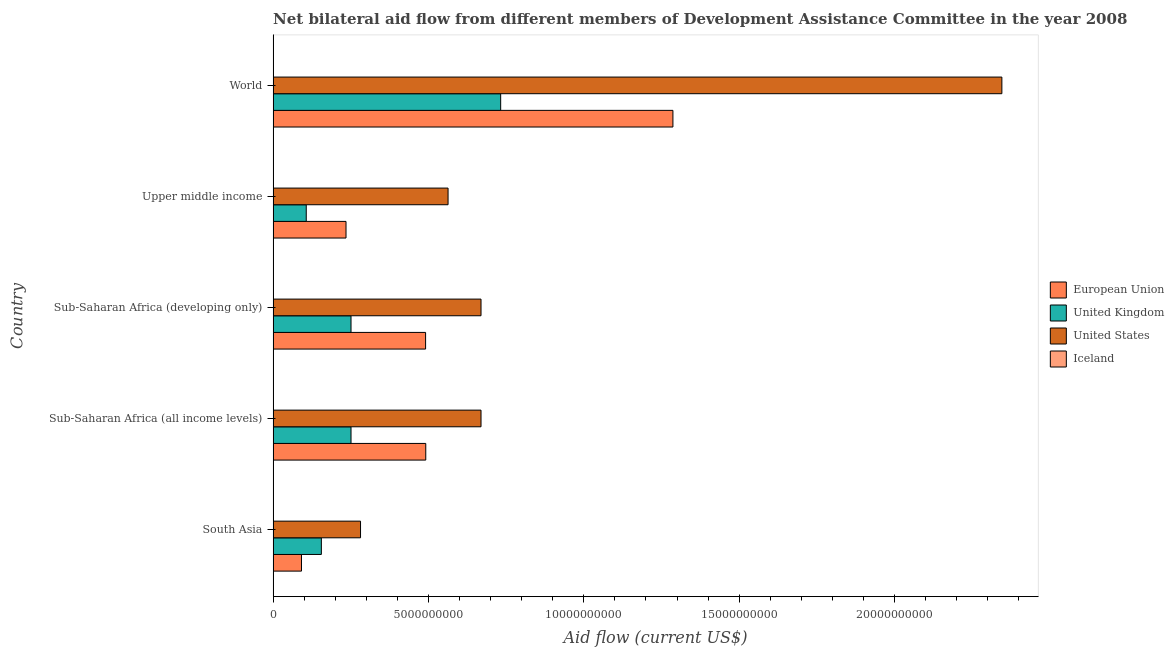How many groups of bars are there?
Make the answer very short. 5. Are the number of bars per tick equal to the number of legend labels?
Make the answer very short. Yes. Are the number of bars on each tick of the Y-axis equal?
Ensure brevity in your answer.  Yes. How many bars are there on the 5th tick from the top?
Provide a succinct answer. 4. How many bars are there on the 2nd tick from the bottom?
Your answer should be compact. 4. What is the label of the 5th group of bars from the top?
Make the answer very short. South Asia. In how many cases, is the number of bars for a given country not equal to the number of legend labels?
Your answer should be compact. 0. What is the amount of aid given by iceland in Sub-Saharan Africa (all income levels)?
Keep it short and to the point. 5.30e+05. Across all countries, what is the maximum amount of aid given by iceland?
Your response must be concise. 5.13e+06. Across all countries, what is the minimum amount of aid given by uk?
Keep it short and to the point. 1.07e+09. In which country was the amount of aid given by uk maximum?
Your response must be concise. World. In which country was the amount of aid given by iceland minimum?
Ensure brevity in your answer.  Sub-Saharan Africa (all income levels). What is the total amount of aid given by eu in the graph?
Make the answer very short. 2.59e+1. What is the difference between the amount of aid given by uk in South Asia and that in Sub-Saharan Africa (developing only)?
Make the answer very short. -9.54e+08. What is the difference between the amount of aid given by eu in South Asia and the amount of aid given by uk in World?
Offer a terse response. -6.41e+09. What is the average amount of aid given by eu per country?
Your response must be concise. 5.19e+09. What is the difference between the amount of aid given by us and amount of aid given by uk in Sub-Saharan Africa (developing only)?
Your response must be concise. 4.18e+09. In how many countries, is the amount of aid given by eu greater than 1000000000 US$?
Give a very brief answer. 4. What is the ratio of the amount of aid given by iceland in Sub-Saharan Africa (developing only) to that in Upper middle income?
Make the answer very short. 1.44. Is the difference between the amount of aid given by iceland in Sub-Saharan Africa (developing only) and World greater than the difference between the amount of aid given by us in Sub-Saharan Africa (developing only) and World?
Make the answer very short. Yes. What is the difference between the highest and the second highest amount of aid given by us?
Ensure brevity in your answer.  1.68e+1. What is the difference between the highest and the lowest amount of aid given by uk?
Offer a terse response. 6.26e+09. What is the difference between two consecutive major ticks on the X-axis?
Offer a very short reply. 5.00e+09. Does the graph contain any zero values?
Keep it short and to the point. No. Does the graph contain grids?
Give a very brief answer. No. How many legend labels are there?
Provide a short and direct response. 4. How are the legend labels stacked?
Provide a short and direct response. Vertical. What is the title of the graph?
Your answer should be compact. Net bilateral aid flow from different members of Development Assistance Committee in the year 2008. What is the Aid flow (current US$) in European Union in South Asia?
Keep it short and to the point. 9.13e+08. What is the Aid flow (current US$) of United Kingdom in South Asia?
Ensure brevity in your answer.  1.55e+09. What is the Aid flow (current US$) in United States in South Asia?
Offer a very short reply. 2.81e+09. What is the Aid flow (current US$) of European Union in Sub-Saharan Africa (all income levels)?
Keep it short and to the point. 4.91e+09. What is the Aid flow (current US$) in United Kingdom in Sub-Saharan Africa (all income levels)?
Make the answer very short. 2.51e+09. What is the Aid flow (current US$) in United States in Sub-Saharan Africa (all income levels)?
Give a very brief answer. 6.69e+09. What is the Aid flow (current US$) of Iceland in Sub-Saharan Africa (all income levels)?
Your answer should be very brief. 5.30e+05. What is the Aid flow (current US$) of European Union in Sub-Saharan Africa (developing only)?
Your answer should be very brief. 4.91e+09. What is the Aid flow (current US$) in United Kingdom in Sub-Saharan Africa (developing only)?
Provide a short and direct response. 2.51e+09. What is the Aid flow (current US$) of United States in Sub-Saharan Africa (developing only)?
Give a very brief answer. 6.69e+09. What is the Aid flow (current US$) of Iceland in Sub-Saharan Africa (developing only)?
Provide a succinct answer. 5.13e+06. What is the Aid flow (current US$) in European Union in Upper middle income?
Offer a terse response. 2.35e+09. What is the Aid flow (current US$) of United Kingdom in Upper middle income?
Provide a short and direct response. 1.07e+09. What is the Aid flow (current US$) in United States in Upper middle income?
Give a very brief answer. 5.63e+09. What is the Aid flow (current US$) of Iceland in Upper middle income?
Ensure brevity in your answer.  3.57e+06. What is the Aid flow (current US$) of European Union in World?
Provide a succinct answer. 1.29e+1. What is the Aid flow (current US$) of United Kingdom in World?
Give a very brief answer. 7.32e+09. What is the Aid flow (current US$) in United States in World?
Your answer should be compact. 2.35e+1. What is the Aid flow (current US$) in Iceland in World?
Provide a succinct answer. 2.64e+06. Across all countries, what is the maximum Aid flow (current US$) in European Union?
Your answer should be very brief. 1.29e+1. Across all countries, what is the maximum Aid flow (current US$) of United Kingdom?
Keep it short and to the point. 7.32e+09. Across all countries, what is the maximum Aid flow (current US$) of United States?
Provide a short and direct response. 2.35e+1. Across all countries, what is the maximum Aid flow (current US$) of Iceland?
Give a very brief answer. 5.13e+06. Across all countries, what is the minimum Aid flow (current US$) of European Union?
Provide a short and direct response. 9.13e+08. Across all countries, what is the minimum Aid flow (current US$) in United Kingdom?
Provide a succinct answer. 1.07e+09. Across all countries, what is the minimum Aid flow (current US$) of United States?
Your answer should be very brief. 2.81e+09. Across all countries, what is the minimum Aid flow (current US$) of Iceland?
Your answer should be compact. 5.30e+05. What is the total Aid flow (current US$) of European Union in the graph?
Offer a terse response. 2.59e+1. What is the total Aid flow (current US$) of United Kingdom in the graph?
Your answer should be compact. 1.50e+1. What is the total Aid flow (current US$) of United States in the graph?
Give a very brief answer. 4.53e+1. What is the total Aid flow (current US$) in Iceland in the graph?
Make the answer very short. 1.24e+07. What is the difference between the Aid flow (current US$) in European Union in South Asia and that in Sub-Saharan Africa (all income levels)?
Make the answer very short. -4.00e+09. What is the difference between the Aid flow (current US$) in United Kingdom in South Asia and that in Sub-Saharan Africa (all income levels)?
Offer a terse response. -9.54e+08. What is the difference between the Aid flow (current US$) in United States in South Asia and that in Sub-Saharan Africa (all income levels)?
Your answer should be very brief. -3.88e+09. What is the difference between the Aid flow (current US$) of European Union in South Asia and that in Sub-Saharan Africa (developing only)?
Your response must be concise. -3.99e+09. What is the difference between the Aid flow (current US$) of United Kingdom in South Asia and that in Sub-Saharan Africa (developing only)?
Your response must be concise. -9.54e+08. What is the difference between the Aid flow (current US$) in United States in South Asia and that in Sub-Saharan Africa (developing only)?
Your answer should be very brief. -3.88e+09. What is the difference between the Aid flow (current US$) in Iceland in South Asia and that in Sub-Saharan Africa (developing only)?
Your response must be concise. -4.58e+06. What is the difference between the Aid flow (current US$) in European Union in South Asia and that in Upper middle income?
Your response must be concise. -1.43e+09. What is the difference between the Aid flow (current US$) of United Kingdom in South Asia and that in Upper middle income?
Give a very brief answer. 4.86e+08. What is the difference between the Aid flow (current US$) in United States in South Asia and that in Upper middle income?
Ensure brevity in your answer.  -2.82e+09. What is the difference between the Aid flow (current US$) of Iceland in South Asia and that in Upper middle income?
Your answer should be very brief. -3.02e+06. What is the difference between the Aid flow (current US$) in European Union in South Asia and that in World?
Your answer should be compact. -1.20e+1. What is the difference between the Aid flow (current US$) of United Kingdom in South Asia and that in World?
Give a very brief answer. -5.77e+09. What is the difference between the Aid flow (current US$) of United States in South Asia and that in World?
Ensure brevity in your answer.  -2.06e+1. What is the difference between the Aid flow (current US$) in Iceland in South Asia and that in World?
Your response must be concise. -2.09e+06. What is the difference between the Aid flow (current US$) in European Union in Sub-Saharan Africa (all income levels) and that in Sub-Saharan Africa (developing only)?
Your answer should be very brief. 5.31e+06. What is the difference between the Aid flow (current US$) of United Kingdom in Sub-Saharan Africa (all income levels) and that in Sub-Saharan Africa (developing only)?
Provide a short and direct response. 0. What is the difference between the Aid flow (current US$) in United States in Sub-Saharan Africa (all income levels) and that in Sub-Saharan Africa (developing only)?
Ensure brevity in your answer.  10000. What is the difference between the Aid flow (current US$) of Iceland in Sub-Saharan Africa (all income levels) and that in Sub-Saharan Africa (developing only)?
Keep it short and to the point. -4.60e+06. What is the difference between the Aid flow (current US$) in European Union in Sub-Saharan Africa (all income levels) and that in Upper middle income?
Give a very brief answer. 2.57e+09. What is the difference between the Aid flow (current US$) of United Kingdom in Sub-Saharan Africa (all income levels) and that in Upper middle income?
Make the answer very short. 1.44e+09. What is the difference between the Aid flow (current US$) of United States in Sub-Saharan Africa (all income levels) and that in Upper middle income?
Make the answer very short. 1.06e+09. What is the difference between the Aid flow (current US$) in Iceland in Sub-Saharan Africa (all income levels) and that in Upper middle income?
Your answer should be very brief. -3.04e+06. What is the difference between the Aid flow (current US$) in European Union in Sub-Saharan Africa (all income levels) and that in World?
Ensure brevity in your answer.  -7.95e+09. What is the difference between the Aid flow (current US$) in United Kingdom in Sub-Saharan Africa (all income levels) and that in World?
Your answer should be very brief. -4.82e+09. What is the difference between the Aid flow (current US$) in United States in Sub-Saharan Africa (all income levels) and that in World?
Provide a short and direct response. -1.68e+1. What is the difference between the Aid flow (current US$) of Iceland in Sub-Saharan Africa (all income levels) and that in World?
Keep it short and to the point. -2.11e+06. What is the difference between the Aid flow (current US$) in European Union in Sub-Saharan Africa (developing only) and that in Upper middle income?
Make the answer very short. 2.56e+09. What is the difference between the Aid flow (current US$) in United Kingdom in Sub-Saharan Africa (developing only) and that in Upper middle income?
Your answer should be compact. 1.44e+09. What is the difference between the Aid flow (current US$) in United States in Sub-Saharan Africa (developing only) and that in Upper middle income?
Offer a terse response. 1.06e+09. What is the difference between the Aid flow (current US$) of Iceland in Sub-Saharan Africa (developing only) and that in Upper middle income?
Your answer should be compact. 1.56e+06. What is the difference between the Aid flow (current US$) in European Union in Sub-Saharan Africa (developing only) and that in World?
Provide a short and direct response. -7.96e+09. What is the difference between the Aid flow (current US$) in United Kingdom in Sub-Saharan Africa (developing only) and that in World?
Provide a succinct answer. -4.82e+09. What is the difference between the Aid flow (current US$) of United States in Sub-Saharan Africa (developing only) and that in World?
Offer a terse response. -1.68e+1. What is the difference between the Aid flow (current US$) of Iceland in Sub-Saharan Africa (developing only) and that in World?
Make the answer very short. 2.49e+06. What is the difference between the Aid flow (current US$) in European Union in Upper middle income and that in World?
Your answer should be very brief. -1.05e+1. What is the difference between the Aid flow (current US$) of United Kingdom in Upper middle income and that in World?
Your answer should be very brief. -6.26e+09. What is the difference between the Aid flow (current US$) of United States in Upper middle income and that in World?
Provide a short and direct response. -1.78e+1. What is the difference between the Aid flow (current US$) of Iceland in Upper middle income and that in World?
Ensure brevity in your answer.  9.30e+05. What is the difference between the Aid flow (current US$) of European Union in South Asia and the Aid flow (current US$) of United Kingdom in Sub-Saharan Africa (all income levels)?
Provide a succinct answer. -1.59e+09. What is the difference between the Aid flow (current US$) of European Union in South Asia and the Aid flow (current US$) of United States in Sub-Saharan Africa (all income levels)?
Ensure brevity in your answer.  -5.78e+09. What is the difference between the Aid flow (current US$) in European Union in South Asia and the Aid flow (current US$) in Iceland in Sub-Saharan Africa (all income levels)?
Your response must be concise. 9.12e+08. What is the difference between the Aid flow (current US$) of United Kingdom in South Asia and the Aid flow (current US$) of United States in Sub-Saharan Africa (all income levels)?
Give a very brief answer. -5.14e+09. What is the difference between the Aid flow (current US$) in United Kingdom in South Asia and the Aid flow (current US$) in Iceland in Sub-Saharan Africa (all income levels)?
Offer a very short reply. 1.55e+09. What is the difference between the Aid flow (current US$) in United States in South Asia and the Aid flow (current US$) in Iceland in Sub-Saharan Africa (all income levels)?
Keep it short and to the point. 2.81e+09. What is the difference between the Aid flow (current US$) of European Union in South Asia and the Aid flow (current US$) of United Kingdom in Sub-Saharan Africa (developing only)?
Offer a terse response. -1.59e+09. What is the difference between the Aid flow (current US$) of European Union in South Asia and the Aid flow (current US$) of United States in Sub-Saharan Africa (developing only)?
Provide a short and direct response. -5.78e+09. What is the difference between the Aid flow (current US$) in European Union in South Asia and the Aid flow (current US$) in Iceland in Sub-Saharan Africa (developing only)?
Make the answer very short. 9.08e+08. What is the difference between the Aid flow (current US$) in United Kingdom in South Asia and the Aid flow (current US$) in United States in Sub-Saharan Africa (developing only)?
Keep it short and to the point. -5.14e+09. What is the difference between the Aid flow (current US$) of United Kingdom in South Asia and the Aid flow (current US$) of Iceland in Sub-Saharan Africa (developing only)?
Your response must be concise. 1.55e+09. What is the difference between the Aid flow (current US$) in United States in South Asia and the Aid flow (current US$) in Iceland in Sub-Saharan Africa (developing only)?
Provide a short and direct response. 2.81e+09. What is the difference between the Aid flow (current US$) in European Union in South Asia and the Aid flow (current US$) in United Kingdom in Upper middle income?
Offer a very short reply. -1.53e+08. What is the difference between the Aid flow (current US$) of European Union in South Asia and the Aid flow (current US$) of United States in Upper middle income?
Offer a very short reply. -4.72e+09. What is the difference between the Aid flow (current US$) of European Union in South Asia and the Aid flow (current US$) of Iceland in Upper middle income?
Offer a very short reply. 9.09e+08. What is the difference between the Aid flow (current US$) in United Kingdom in South Asia and the Aid flow (current US$) in United States in Upper middle income?
Your answer should be very brief. -4.08e+09. What is the difference between the Aid flow (current US$) in United Kingdom in South Asia and the Aid flow (current US$) in Iceland in Upper middle income?
Make the answer very short. 1.55e+09. What is the difference between the Aid flow (current US$) in United States in South Asia and the Aid flow (current US$) in Iceland in Upper middle income?
Provide a short and direct response. 2.81e+09. What is the difference between the Aid flow (current US$) of European Union in South Asia and the Aid flow (current US$) of United Kingdom in World?
Keep it short and to the point. -6.41e+09. What is the difference between the Aid flow (current US$) in European Union in South Asia and the Aid flow (current US$) in United States in World?
Your answer should be very brief. -2.25e+1. What is the difference between the Aid flow (current US$) of European Union in South Asia and the Aid flow (current US$) of Iceland in World?
Provide a short and direct response. 9.10e+08. What is the difference between the Aid flow (current US$) of United Kingdom in South Asia and the Aid flow (current US$) of United States in World?
Provide a short and direct response. -2.19e+1. What is the difference between the Aid flow (current US$) in United Kingdom in South Asia and the Aid flow (current US$) in Iceland in World?
Offer a very short reply. 1.55e+09. What is the difference between the Aid flow (current US$) in United States in South Asia and the Aid flow (current US$) in Iceland in World?
Offer a very short reply. 2.81e+09. What is the difference between the Aid flow (current US$) in European Union in Sub-Saharan Africa (all income levels) and the Aid flow (current US$) in United Kingdom in Sub-Saharan Africa (developing only)?
Your response must be concise. 2.41e+09. What is the difference between the Aid flow (current US$) of European Union in Sub-Saharan Africa (all income levels) and the Aid flow (current US$) of United States in Sub-Saharan Africa (developing only)?
Give a very brief answer. -1.78e+09. What is the difference between the Aid flow (current US$) in European Union in Sub-Saharan Africa (all income levels) and the Aid flow (current US$) in Iceland in Sub-Saharan Africa (developing only)?
Your answer should be compact. 4.91e+09. What is the difference between the Aid flow (current US$) in United Kingdom in Sub-Saharan Africa (all income levels) and the Aid flow (current US$) in United States in Sub-Saharan Africa (developing only)?
Give a very brief answer. -4.18e+09. What is the difference between the Aid flow (current US$) in United Kingdom in Sub-Saharan Africa (all income levels) and the Aid flow (current US$) in Iceland in Sub-Saharan Africa (developing only)?
Offer a very short reply. 2.50e+09. What is the difference between the Aid flow (current US$) in United States in Sub-Saharan Africa (all income levels) and the Aid flow (current US$) in Iceland in Sub-Saharan Africa (developing only)?
Offer a terse response. 6.69e+09. What is the difference between the Aid flow (current US$) of European Union in Sub-Saharan Africa (all income levels) and the Aid flow (current US$) of United Kingdom in Upper middle income?
Ensure brevity in your answer.  3.85e+09. What is the difference between the Aid flow (current US$) in European Union in Sub-Saharan Africa (all income levels) and the Aid flow (current US$) in United States in Upper middle income?
Offer a very short reply. -7.18e+08. What is the difference between the Aid flow (current US$) of European Union in Sub-Saharan Africa (all income levels) and the Aid flow (current US$) of Iceland in Upper middle income?
Make the answer very short. 4.91e+09. What is the difference between the Aid flow (current US$) in United Kingdom in Sub-Saharan Africa (all income levels) and the Aid flow (current US$) in United States in Upper middle income?
Give a very brief answer. -3.12e+09. What is the difference between the Aid flow (current US$) of United Kingdom in Sub-Saharan Africa (all income levels) and the Aid flow (current US$) of Iceland in Upper middle income?
Your response must be concise. 2.50e+09. What is the difference between the Aid flow (current US$) of United States in Sub-Saharan Africa (all income levels) and the Aid flow (current US$) of Iceland in Upper middle income?
Your answer should be very brief. 6.69e+09. What is the difference between the Aid flow (current US$) of European Union in Sub-Saharan Africa (all income levels) and the Aid flow (current US$) of United Kingdom in World?
Provide a succinct answer. -2.41e+09. What is the difference between the Aid flow (current US$) in European Union in Sub-Saharan Africa (all income levels) and the Aid flow (current US$) in United States in World?
Give a very brief answer. -1.85e+1. What is the difference between the Aid flow (current US$) in European Union in Sub-Saharan Africa (all income levels) and the Aid flow (current US$) in Iceland in World?
Keep it short and to the point. 4.91e+09. What is the difference between the Aid flow (current US$) in United Kingdom in Sub-Saharan Africa (all income levels) and the Aid flow (current US$) in United States in World?
Give a very brief answer. -2.09e+1. What is the difference between the Aid flow (current US$) in United Kingdom in Sub-Saharan Africa (all income levels) and the Aid flow (current US$) in Iceland in World?
Your response must be concise. 2.50e+09. What is the difference between the Aid flow (current US$) in United States in Sub-Saharan Africa (all income levels) and the Aid flow (current US$) in Iceland in World?
Your answer should be very brief. 6.69e+09. What is the difference between the Aid flow (current US$) in European Union in Sub-Saharan Africa (developing only) and the Aid flow (current US$) in United Kingdom in Upper middle income?
Your answer should be very brief. 3.84e+09. What is the difference between the Aid flow (current US$) in European Union in Sub-Saharan Africa (developing only) and the Aid flow (current US$) in United States in Upper middle income?
Provide a short and direct response. -7.23e+08. What is the difference between the Aid flow (current US$) in European Union in Sub-Saharan Africa (developing only) and the Aid flow (current US$) in Iceland in Upper middle income?
Your response must be concise. 4.90e+09. What is the difference between the Aid flow (current US$) of United Kingdom in Sub-Saharan Africa (developing only) and the Aid flow (current US$) of United States in Upper middle income?
Keep it short and to the point. -3.12e+09. What is the difference between the Aid flow (current US$) in United Kingdom in Sub-Saharan Africa (developing only) and the Aid flow (current US$) in Iceland in Upper middle income?
Provide a succinct answer. 2.50e+09. What is the difference between the Aid flow (current US$) of United States in Sub-Saharan Africa (developing only) and the Aid flow (current US$) of Iceland in Upper middle income?
Offer a terse response. 6.69e+09. What is the difference between the Aid flow (current US$) in European Union in Sub-Saharan Africa (developing only) and the Aid flow (current US$) in United Kingdom in World?
Provide a short and direct response. -2.42e+09. What is the difference between the Aid flow (current US$) in European Union in Sub-Saharan Africa (developing only) and the Aid flow (current US$) in United States in World?
Your response must be concise. -1.85e+1. What is the difference between the Aid flow (current US$) of European Union in Sub-Saharan Africa (developing only) and the Aid flow (current US$) of Iceland in World?
Provide a succinct answer. 4.90e+09. What is the difference between the Aid flow (current US$) of United Kingdom in Sub-Saharan Africa (developing only) and the Aid flow (current US$) of United States in World?
Give a very brief answer. -2.09e+1. What is the difference between the Aid flow (current US$) of United Kingdom in Sub-Saharan Africa (developing only) and the Aid flow (current US$) of Iceland in World?
Give a very brief answer. 2.50e+09. What is the difference between the Aid flow (current US$) of United States in Sub-Saharan Africa (developing only) and the Aid flow (current US$) of Iceland in World?
Your answer should be very brief. 6.69e+09. What is the difference between the Aid flow (current US$) of European Union in Upper middle income and the Aid flow (current US$) of United Kingdom in World?
Make the answer very short. -4.98e+09. What is the difference between the Aid flow (current US$) in European Union in Upper middle income and the Aid flow (current US$) in United States in World?
Keep it short and to the point. -2.11e+1. What is the difference between the Aid flow (current US$) in European Union in Upper middle income and the Aid flow (current US$) in Iceland in World?
Offer a terse response. 2.34e+09. What is the difference between the Aid flow (current US$) in United Kingdom in Upper middle income and the Aid flow (current US$) in United States in World?
Offer a terse response. -2.24e+1. What is the difference between the Aid flow (current US$) in United Kingdom in Upper middle income and the Aid flow (current US$) in Iceland in World?
Offer a terse response. 1.06e+09. What is the difference between the Aid flow (current US$) in United States in Upper middle income and the Aid flow (current US$) in Iceland in World?
Provide a succinct answer. 5.63e+09. What is the average Aid flow (current US$) of European Union per country?
Offer a terse response. 5.19e+09. What is the average Aid flow (current US$) in United Kingdom per country?
Your answer should be compact. 2.99e+09. What is the average Aid flow (current US$) of United States per country?
Your answer should be compact. 9.06e+09. What is the average Aid flow (current US$) of Iceland per country?
Provide a short and direct response. 2.48e+06. What is the difference between the Aid flow (current US$) in European Union and Aid flow (current US$) in United Kingdom in South Asia?
Provide a succinct answer. -6.40e+08. What is the difference between the Aid flow (current US$) in European Union and Aid flow (current US$) in United States in South Asia?
Offer a very short reply. -1.90e+09. What is the difference between the Aid flow (current US$) in European Union and Aid flow (current US$) in Iceland in South Asia?
Make the answer very short. 9.12e+08. What is the difference between the Aid flow (current US$) in United Kingdom and Aid flow (current US$) in United States in South Asia?
Provide a succinct answer. -1.26e+09. What is the difference between the Aid flow (current US$) in United Kingdom and Aid flow (current US$) in Iceland in South Asia?
Provide a succinct answer. 1.55e+09. What is the difference between the Aid flow (current US$) in United States and Aid flow (current US$) in Iceland in South Asia?
Keep it short and to the point. 2.81e+09. What is the difference between the Aid flow (current US$) of European Union and Aid flow (current US$) of United Kingdom in Sub-Saharan Africa (all income levels)?
Offer a terse response. 2.41e+09. What is the difference between the Aid flow (current US$) of European Union and Aid flow (current US$) of United States in Sub-Saharan Africa (all income levels)?
Your answer should be compact. -1.78e+09. What is the difference between the Aid flow (current US$) in European Union and Aid flow (current US$) in Iceland in Sub-Saharan Africa (all income levels)?
Offer a very short reply. 4.91e+09. What is the difference between the Aid flow (current US$) of United Kingdom and Aid flow (current US$) of United States in Sub-Saharan Africa (all income levels)?
Keep it short and to the point. -4.18e+09. What is the difference between the Aid flow (current US$) in United Kingdom and Aid flow (current US$) in Iceland in Sub-Saharan Africa (all income levels)?
Your answer should be very brief. 2.51e+09. What is the difference between the Aid flow (current US$) in United States and Aid flow (current US$) in Iceland in Sub-Saharan Africa (all income levels)?
Give a very brief answer. 6.69e+09. What is the difference between the Aid flow (current US$) in European Union and Aid flow (current US$) in United Kingdom in Sub-Saharan Africa (developing only)?
Give a very brief answer. 2.40e+09. What is the difference between the Aid flow (current US$) in European Union and Aid flow (current US$) in United States in Sub-Saharan Africa (developing only)?
Give a very brief answer. -1.78e+09. What is the difference between the Aid flow (current US$) of European Union and Aid flow (current US$) of Iceland in Sub-Saharan Africa (developing only)?
Make the answer very short. 4.90e+09. What is the difference between the Aid flow (current US$) in United Kingdom and Aid flow (current US$) in United States in Sub-Saharan Africa (developing only)?
Make the answer very short. -4.18e+09. What is the difference between the Aid flow (current US$) in United Kingdom and Aid flow (current US$) in Iceland in Sub-Saharan Africa (developing only)?
Ensure brevity in your answer.  2.50e+09. What is the difference between the Aid flow (current US$) of United States and Aid flow (current US$) of Iceland in Sub-Saharan Africa (developing only)?
Provide a succinct answer. 6.69e+09. What is the difference between the Aid flow (current US$) in European Union and Aid flow (current US$) in United Kingdom in Upper middle income?
Your answer should be very brief. 1.28e+09. What is the difference between the Aid flow (current US$) in European Union and Aid flow (current US$) in United States in Upper middle income?
Your response must be concise. -3.28e+09. What is the difference between the Aid flow (current US$) of European Union and Aid flow (current US$) of Iceland in Upper middle income?
Offer a very short reply. 2.34e+09. What is the difference between the Aid flow (current US$) in United Kingdom and Aid flow (current US$) in United States in Upper middle income?
Ensure brevity in your answer.  -4.56e+09. What is the difference between the Aid flow (current US$) of United Kingdom and Aid flow (current US$) of Iceland in Upper middle income?
Your response must be concise. 1.06e+09. What is the difference between the Aid flow (current US$) in United States and Aid flow (current US$) in Iceland in Upper middle income?
Provide a short and direct response. 5.63e+09. What is the difference between the Aid flow (current US$) of European Union and Aid flow (current US$) of United Kingdom in World?
Give a very brief answer. 5.54e+09. What is the difference between the Aid flow (current US$) in European Union and Aid flow (current US$) in United States in World?
Make the answer very short. -1.06e+1. What is the difference between the Aid flow (current US$) in European Union and Aid flow (current US$) in Iceland in World?
Keep it short and to the point. 1.29e+1. What is the difference between the Aid flow (current US$) in United Kingdom and Aid flow (current US$) in United States in World?
Your answer should be very brief. -1.61e+1. What is the difference between the Aid flow (current US$) of United Kingdom and Aid flow (current US$) of Iceland in World?
Offer a terse response. 7.32e+09. What is the difference between the Aid flow (current US$) of United States and Aid flow (current US$) of Iceland in World?
Your answer should be compact. 2.35e+1. What is the ratio of the Aid flow (current US$) in European Union in South Asia to that in Sub-Saharan Africa (all income levels)?
Give a very brief answer. 0.19. What is the ratio of the Aid flow (current US$) of United Kingdom in South Asia to that in Sub-Saharan Africa (all income levels)?
Keep it short and to the point. 0.62. What is the ratio of the Aid flow (current US$) of United States in South Asia to that in Sub-Saharan Africa (all income levels)?
Give a very brief answer. 0.42. What is the ratio of the Aid flow (current US$) in Iceland in South Asia to that in Sub-Saharan Africa (all income levels)?
Ensure brevity in your answer.  1.04. What is the ratio of the Aid flow (current US$) of European Union in South Asia to that in Sub-Saharan Africa (developing only)?
Keep it short and to the point. 0.19. What is the ratio of the Aid flow (current US$) in United Kingdom in South Asia to that in Sub-Saharan Africa (developing only)?
Make the answer very short. 0.62. What is the ratio of the Aid flow (current US$) of United States in South Asia to that in Sub-Saharan Africa (developing only)?
Your answer should be compact. 0.42. What is the ratio of the Aid flow (current US$) in Iceland in South Asia to that in Sub-Saharan Africa (developing only)?
Ensure brevity in your answer.  0.11. What is the ratio of the Aid flow (current US$) in European Union in South Asia to that in Upper middle income?
Provide a succinct answer. 0.39. What is the ratio of the Aid flow (current US$) in United Kingdom in South Asia to that in Upper middle income?
Ensure brevity in your answer.  1.46. What is the ratio of the Aid flow (current US$) of United States in South Asia to that in Upper middle income?
Ensure brevity in your answer.  0.5. What is the ratio of the Aid flow (current US$) of Iceland in South Asia to that in Upper middle income?
Keep it short and to the point. 0.15. What is the ratio of the Aid flow (current US$) in European Union in South Asia to that in World?
Provide a short and direct response. 0.07. What is the ratio of the Aid flow (current US$) in United Kingdom in South Asia to that in World?
Give a very brief answer. 0.21. What is the ratio of the Aid flow (current US$) of United States in South Asia to that in World?
Provide a succinct answer. 0.12. What is the ratio of the Aid flow (current US$) of Iceland in South Asia to that in World?
Ensure brevity in your answer.  0.21. What is the ratio of the Aid flow (current US$) in United Kingdom in Sub-Saharan Africa (all income levels) to that in Sub-Saharan Africa (developing only)?
Provide a short and direct response. 1. What is the ratio of the Aid flow (current US$) of Iceland in Sub-Saharan Africa (all income levels) to that in Sub-Saharan Africa (developing only)?
Your answer should be compact. 0.1. What is the ratio of the Aid flow (current US$) in European Union in Sub-Saharan Africa (all income levels) to that in Upper middle income?
Your response must be concise. 2.09. What is the ratio of the Aid flow (current US$) of United Kingdom in Sub-Saharan Africa (all income levels) to that in Upper middle income?
Make the answer very short. 2.35. What is the ratio of the Aid flow (current US$) of United States in Sub-Saharan Africa (all income levels) to that in Upper middle income?
Give a very brief answer. 1.19. What is the ratio of the Aid flow (current US$) in Iceland in Sub-Saharan Africa (all income levels) to that in Upper middle income?
Make the answer very short. 0.15. What is the ratio of the Aid flow (current US$) of European Union in Sub-Saharan Africa (all income levels) to that in World?
Your answer should be compact. 0.38. What is the ratio of the Aid flow (current US$) of United Kingdom in Sub-Saharan Africa (all income levels) to that in World?
Offer a terse response. 0.34. What is the ratio of the Aid flow (current US$) of United States in Sub-Saharan Africa (all income levels) to that in World?
Provide a succinct answer. 0.29. What is the ratio of the Aid flow (current US$) in Iceland in Sub-Saharan Africa (all income levels) to that in World?
Ensure brevity in your answer.  0.2. What is the ratio of the Aid flow (current US$) in European Union in Sub-Saharan Africa (developing only) to that in Upper middle income?
Provide a short and direct response. 2.09. What is the ratio of the Aid flow (current US$) in United Kingdom in Sub-Saharan Africa (developing only) to that in Upper middle income?
Give a very brief answer. 2.35. What is the ratio of the Aid flow (current US$) of United States in Sub-Saharan Africa (developing only) to that in Upper middle income?
Offer a terse response. 1.19. What is the ratio of the Aid flow (current US$) of Iceland in Sub-Saharan Africa (developing only) to that in Upper middle income?
Ensure brevity in your answer.  1.44. What is the ratio of the Aid flow (current US$) in European Union in Sub-Saharan Africa (developing only) to that in World?
Give a very brief answer. 0.38. What is the ratio of the Aid flow (current US$) of United Kingdom in Sub-Saharan Africa (developing only) to that in World?
Your answer should be compact. 0.34. What is the ratio of the Aid flow (current US$) in United States in Sub-Saharan Africa (developing only) to that in World?
Offer a terse response. 0.29. What is the ratio of the Aid flow (current US$) of Iceland in Sub-Saharan Africa (developing only) to that in World?
Your response must be concise. 1.94. What is the ratio of the Aid flow (current US$) in European Union in Upper middle income to that in World?
Your answer should be very brief. 0.18. What is the ratio of the Aid flow (current US$) in United Kingdom in Upper middle income to that in World?
Your answer should be very brief. 0.15. What is the ratio of the Aid flow (current US$) in United States in Upper middle income to that in World?
Keep it short and to the point. 0.24. What is the ratio of the Aid flow (current US$) in Iceland in Upper middle income to that in World?
Ensure brevity in your answer.  1.35. What is the difference between the highest and the second highest Aid flow (current US$) in European Union?
Provide a succinct answer. 7.95e+09. What is the difference between the highest and the second highest Aid flow (current US$) of United Kingdom?
Provide a succinct answer. 4.82e+09. What is the difference between the highest and the second highest Aid flow (current US$) of United States?
Give a very brief answer. 1.68e+1. What is the difference between the highest and the second highest Aid flow (current US$) in Iceland?
Keep it short and to the point. 1.56e+06. What is the difference between the highest and the lowest Aid flow (current US$) in European Union?
Your answer should be compact. 1.20e+1. What is the difference between the highest and the lowest Aid flow (current US$) of United Kingdom?
Offer a very short reply. 6.26e+09. What is the difference between the highest and the lowest Aid flow (current US$) of United States?
Your answer should be compact. 2.06e+1. What is the difference between the highest and the lowest Aid flow (current US$) of Iceland?
Ensure brevity in your answer.  4.60e+06. 